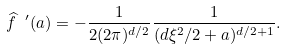<formula> <loc_0><loc_0><loc_500><loc_500>\widehat { f } \ ^ { \prime } ( a ) = - \frac { 1 } { 2 ( 2 \pi ) ^ { d / 2 } } \frac { 1 } { ( d \xi ^ { 2 } / 2 + a ) ^ { d / 2 + 1 } } .</formula> 